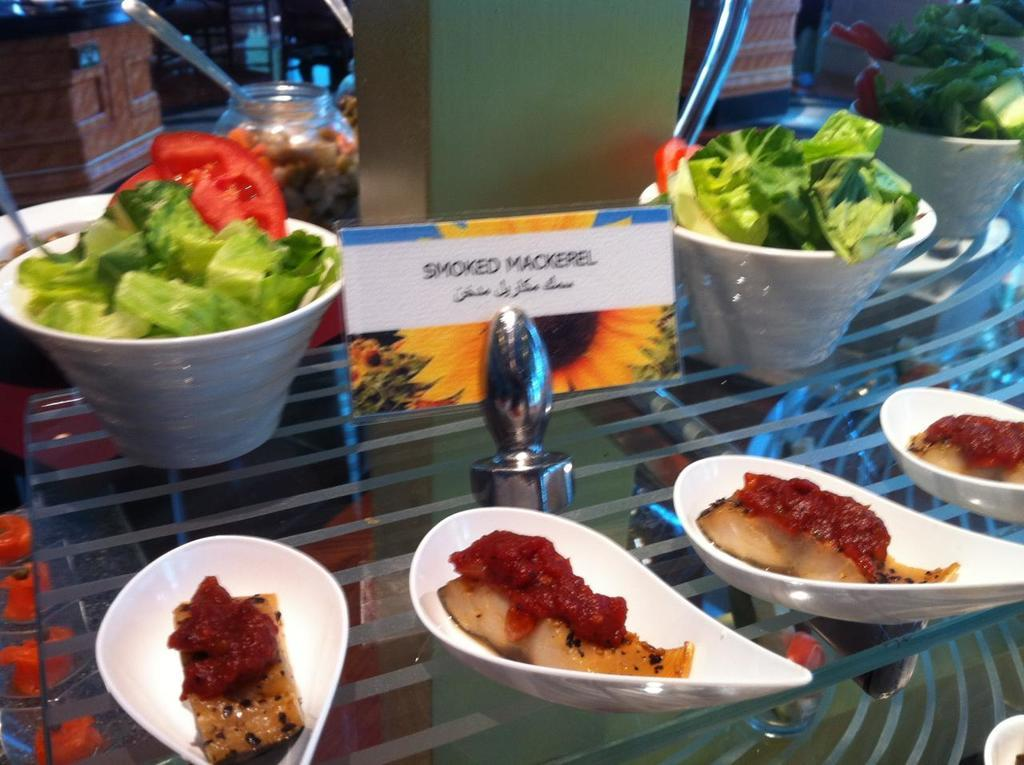What types of objects can be seen in the image? There are food items in the image. How are the food items arranged or presented? The food items are in different kinds of bowls. Is there any text or labeling in the image? Yes, there is a name of an item in the middle of the image. What type of afterthought is depicted in the image? There is no afterthought depicted in the image; it features food items in different kinds of bowls and a name of an item. How does the mist affect the visibility of the food items in the image? There is no mist present in the image, so it does not affect the visibility of the food items. 